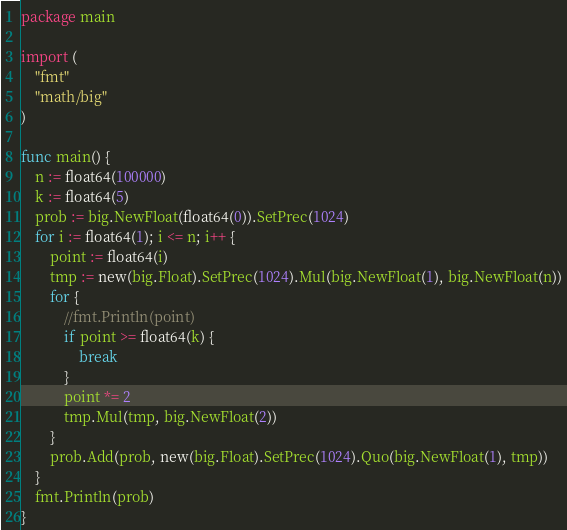Convert code to text. <code><loc_0><loc_0><loc_500><loc_500><_Go_>package main

import (
	"fmt"
	"math/big"
)

func main() {
	n := float64(100000)
	k := float64(5)
	prob := big.NewFloat(float64(0)).SetPrec(1024)
	for i := float64(1); i <= n; i++ {
		point := float64(i)
		tmp := new(big.Float).SetPrec(1024).Mul(big.NewFloat(1), big.NewFloat(n))
		for {
			//fmt.Println(point)
			if point >= float64(k) {
				break
			}
			point *= 2
			tmp.Mul(tmp, big.NewFloat(2))
		}
		prob.Add(prob, new(big.Float).SetPrec(1024).Quo(big.NewFloat(1), tmp))
	}
	fmt.Println(prob)
}
</code> 